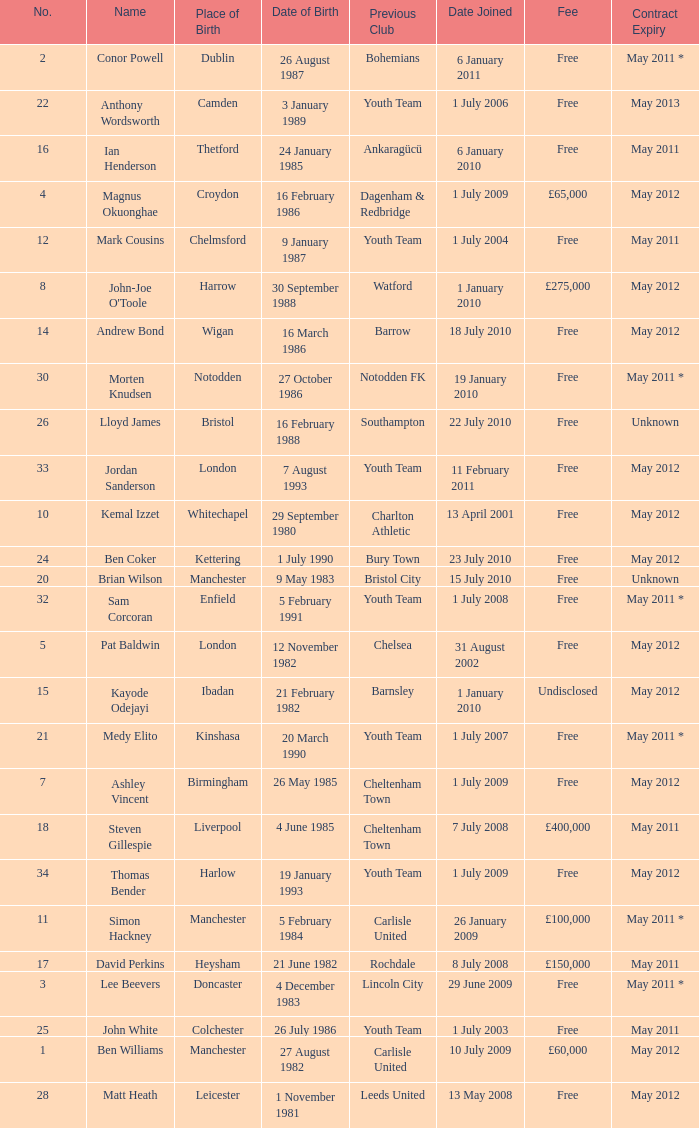For the ben williams name what was the previous club Carlisle United. 